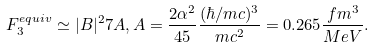Convert formula to latex. <formula><loc_0><loc_0><loc_500><loc_500>F _ { 3 } ^ { e q u i v } \simeq | B | ^ { 2 } 7 A , A = \frac { 2 \alpha ^ { 2 } } { 4 5 } \frac { ( \hbar { / } m c ) ^ { 3 } } { m c ^ { 2 } } = 0 . 2 6 5 \frac { f m ^ { 3 } } { M e V } .</formula> 